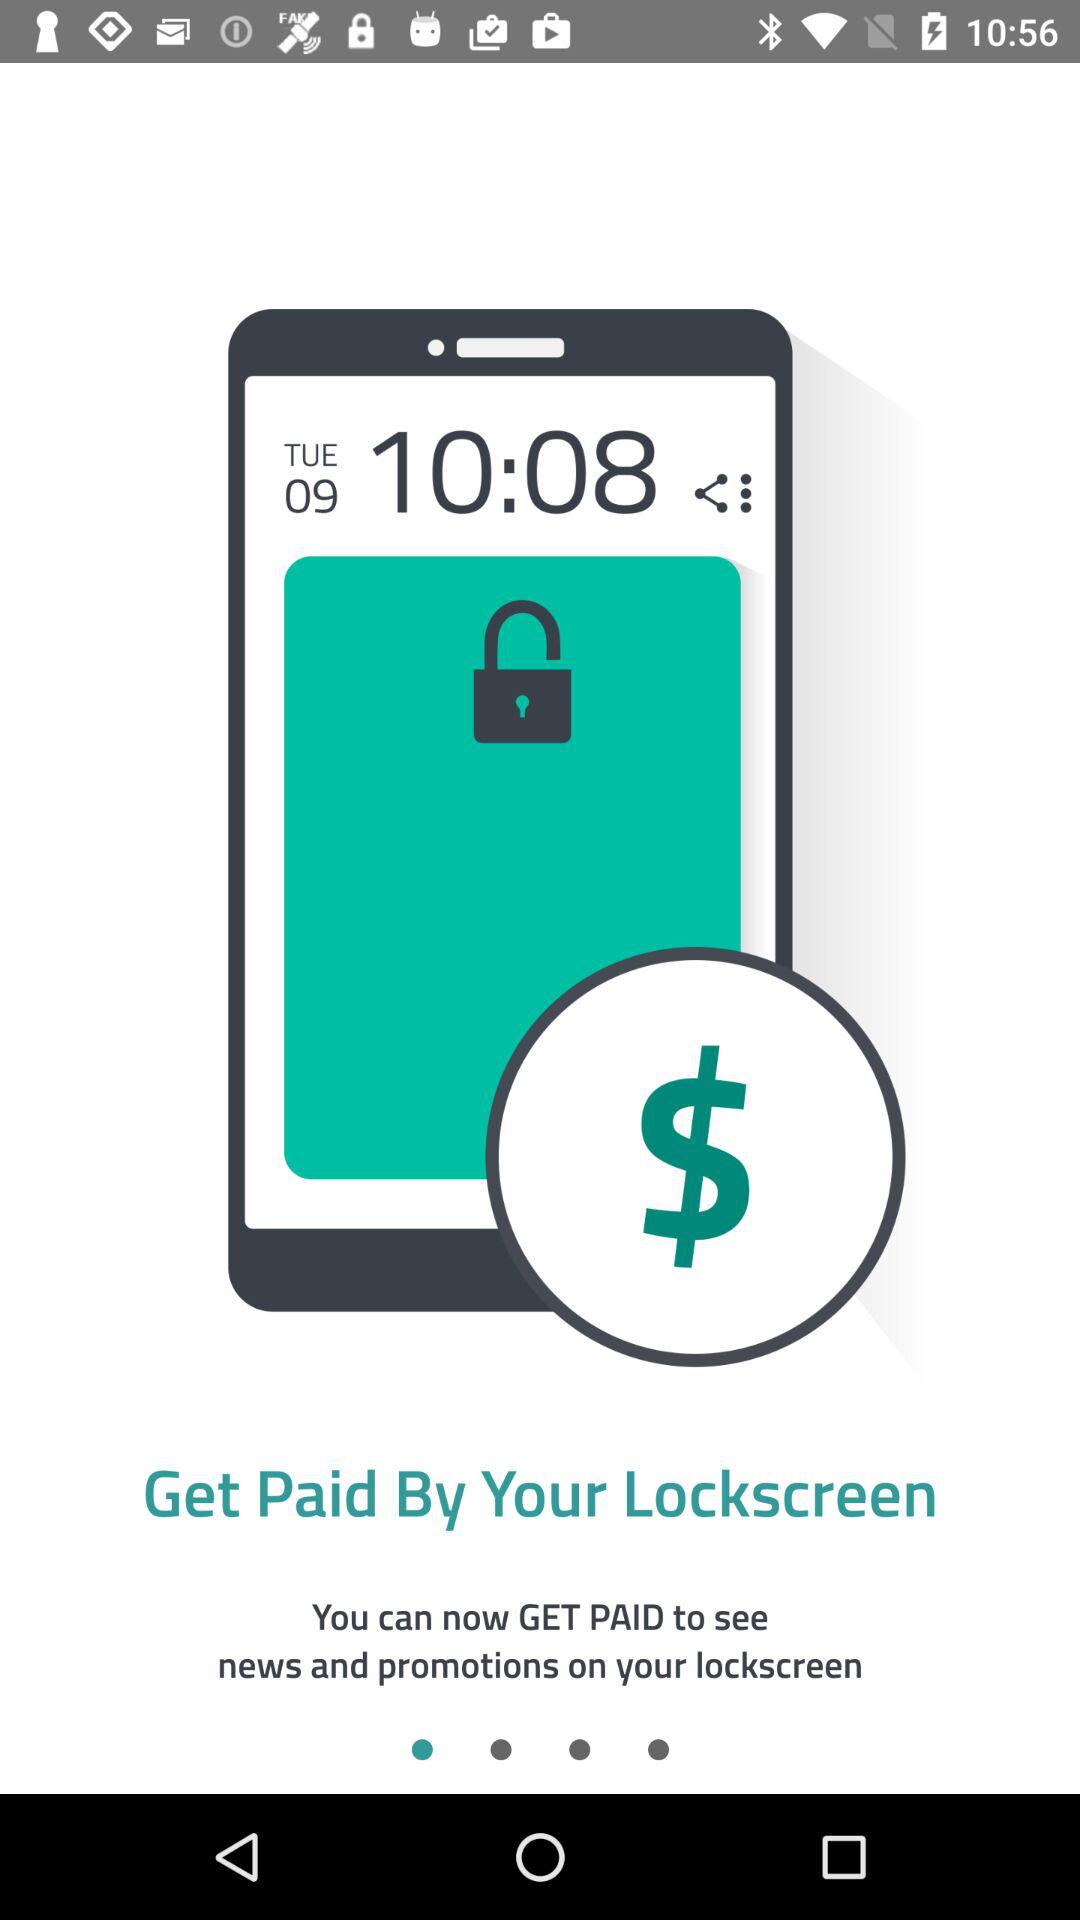What date and time is shown on the display? The shown date is Tuesday 09 and the time is 10:08. 